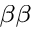Convert formula to latex. <formula><loc_0><loc_0><loc_500><loc_500>_ { \beta \beta }</formula> 